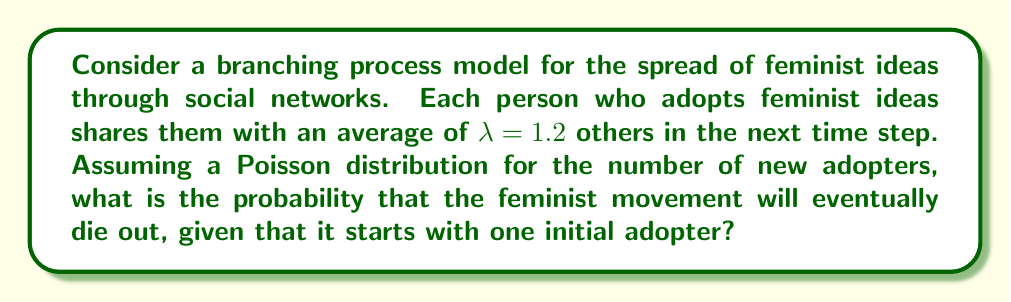Teach me how to tackle this problem. To solve this problem, we'll use the theory of branching processes:

1. In a branching process, the probability of extinction is given by the smallest non-negative root of the equation:
   $$s = G(s)$$
   where $G(s)$ is the probability generating function of the offspring distribution.

2. For a Poisson distribution with mean $\lambda$, the probability generating function is:
   $$G(s) = e^{\lambda(s-1)}$$

3. Substituting this into our equation:
   $$s = e^{\lambda(s-1)}$$

4. We need to solve this equation for $s$. There's always a trivial solution $s=1$, but we're looking for the smallest non-negative root.

5. For $\lambda \leq 1$, the only solution is $s=1$, meaning certain extinction.
   For $\lambda > 1$, there's a solution $0 < s < 1$, which is the probability of extinction.

6. In our case, $\lambda = 1.2 > 1$, so we need to solve:
   $$s = e^{1.2(s-1)}$$

7. This equation can't be solved analytically, so we need to use numerical methods.
   Using a computer or calculator, we find that the solution is approximately:
   $$s \approx 0.7568$$

8. This value of $s$ represents the probability that the process will eventually die out, starting from one initial adopter.
Answer: 0.7568 